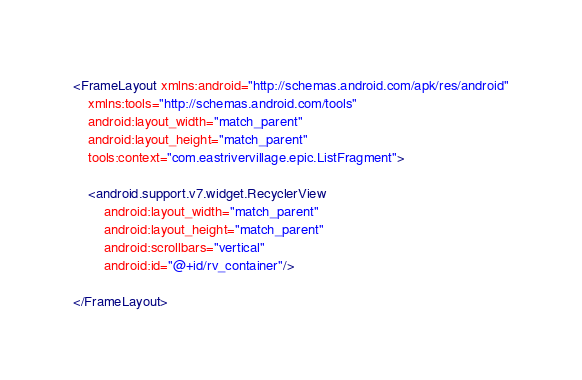Convert code to text. <code><loc_0><loc_0><loc_500><loc_500><_XML_><FrameLayout xmlns:android="http://schemas.android.com/apk/res/android"
    xmlns:tools="http://schemas.android.com/tools"
    android:layout_width="match_parent"
    android:layout_height="match_parent"
    tools:context="com.eastrivervillage.epic.ListFragment">

    <android.support.v7.widget.RecyclerView
        android:layout_width="match_parent"
        android:layout_height="match_parent"
        android:scrollbars="vertical"
        android:id="@+id/rv_container"/>

</FrameLayout>
</code> 